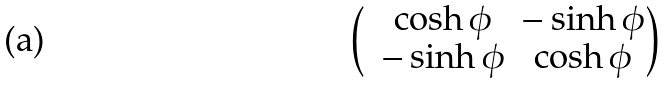Convert formula to latex. <formula><loc_0><loc_0><loc_500><loc_500>\begin{pmatrix} & \cosh \phi & - \sinh \phi \\ & - \sinh \phi & \cosh \phi \end{pmatrix}</formula> 